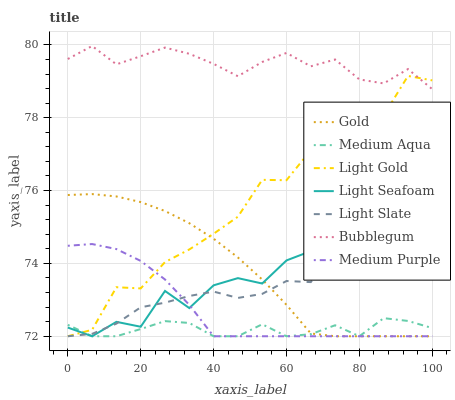Does Medium Aqua have the minimum area under the curve?
Answer yes or no. Yes. Does Bubblegum have the maximum area under the curve?
Answer yes or no. Yes. Does Light Slate have the minimum area under the curve?
Answer yes or no. No. Does Light Slate have the maximum area under the curve?
Answer yes or no. No. Is Gold the smoothest?
Answer yes or no. Yes. Is Light Gold the roughest?
Answer yes or no. Yes. Is Light Slate the smoothest?
Answer yes or no. No. Is Light Slate the roughest?
Answer yes or no. No. Does Bubblegum have the lowest value?
Answer yes or no. No. Does Bubblegum have the highest value?
Answer yes or no. Yes. Does Light Slate have the highest value?
Answer yes or no. No. Is Medium Purple less than Bubblegum?
Answer yes or no. Yes. Is Bubblegum greater than Light Seafoam?
Answer yes or no. Yes. Does Light Seafoam intersect Medium Purple?
Answer yes or no. Yes. Is Light Seafoam less than Medium Purple?
Answer yes or no. No. Is Light Seafoam greater than Medium Purple?
Answer yes or no. No. Does Medium Purple intersect Bubblegum?
Answer yes or no. No. 